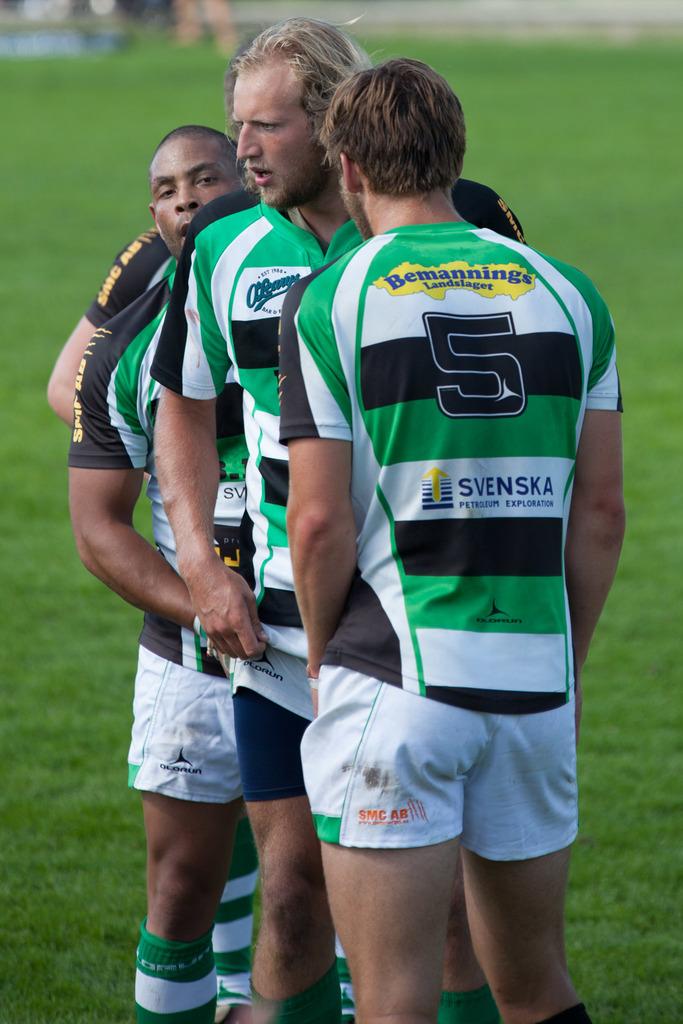What is the player's number?
Offer a terse response. 5. What is written at the top of the green shirt?
Offer a terse response. Bemannings landslaget. 